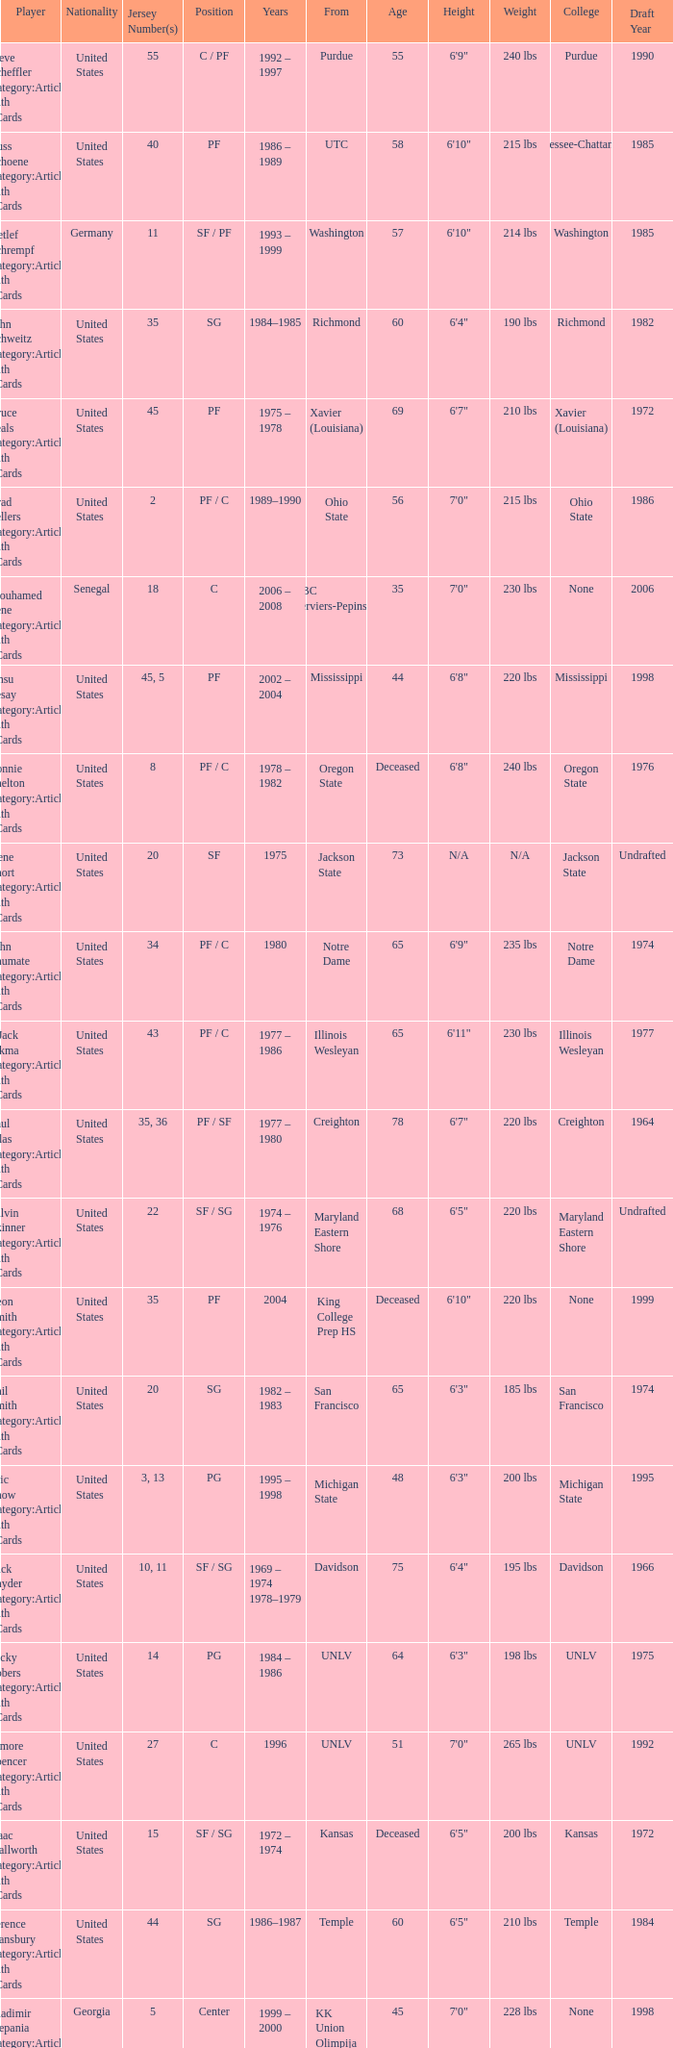What nationality is the player from Oregon State? United States. 